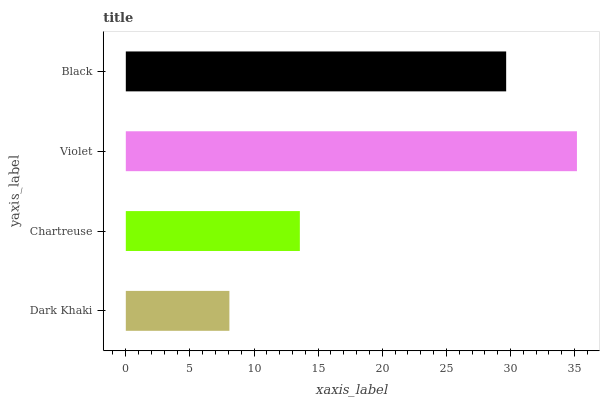Is Dark Khaki the minimum?
Answer yes or no. Yes. Is Violet the maximum?
Answer yes or no. Yes. Is Chartreuse the minimum?
Answer yes or no. No. Is Chartreuse the maximum?
Answer yes or no. No. Is Chartreuse greater than Dark Khaki?
Answer yes or no. Yes. Is Dark Khaki less than Chartreuse?
Answer yes or no. Yes. Is Dark Khaki greater than Chartreuse?
Answer yes or no. No. Is Chartreuse less than Dark Khaki?
Answer yes or no. No. Is Black the high median?
Answer yes or no. Yes. Is Chartreuse the low median?
Answer yes or no. Yes. Is Chartreuse the high median?
Answer yes or no. No. Is Black the low median?
Answer yes or no. No. 